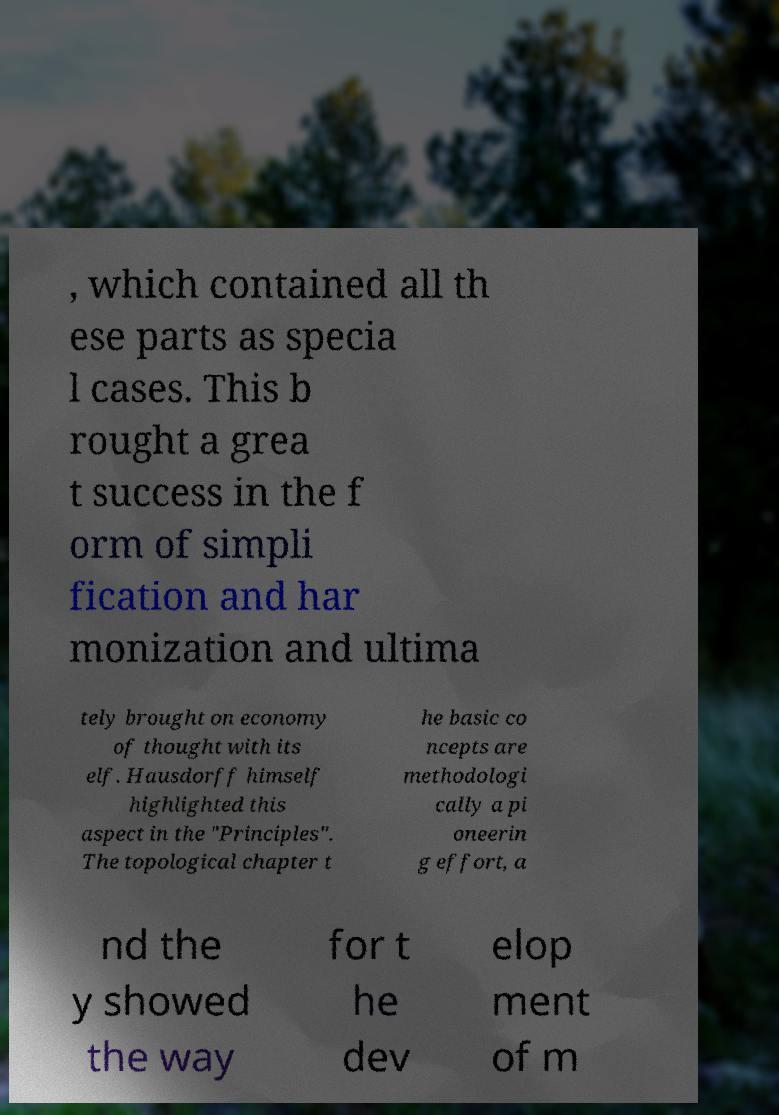What messages or text are displayed in this image? I need them in a readable, typed format. , which contained all th ese parts as specia l cases. This b rought a grea t success in the f orm of simpli fication and har monization and ultima tely brought on economy of thought with its elf. Hausdorff himself highlighted this aspect in the "Principles". The topological chapter t he basic co ncepts are methodologi cally a pi oneerin g effort, a nd the y showed the way for t he dev elop ment of m 